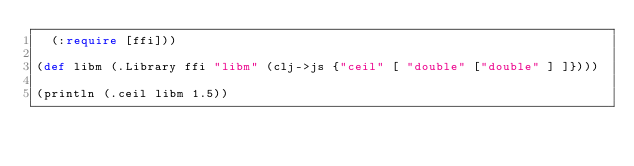<code> <loc_0><loc_0><loc_500><loc_500><_Clojure_>  (:require [ffi]))

(def libm (.Library ffi "libm" (clj->js {"ceil" [ "double" ["double" ] ]})))

(println (.ceil libm 1.5))
</code> 